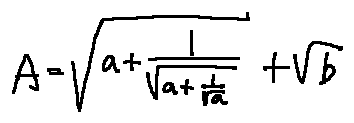<formula> <loc_0><loc_0><loc_500><loc_500>A = \sqrt { a + \frac { 1 } { \sqrt { a + \frac { 1 } { \sqrt { a } } } } } + \sqrt { b }</formula> 